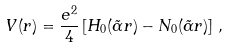Convert formula to latex. <formula><loc_0><loc_0><loc_500><loc_500>V ( r ) = \frac { e ^ { 2 } } { 4 } \left [ H _ { 0 } ( \tilde { \alpha } r ) - N _ { 0 } ( \tilde { \alpha } r ) \right ] \, ,</formula> 